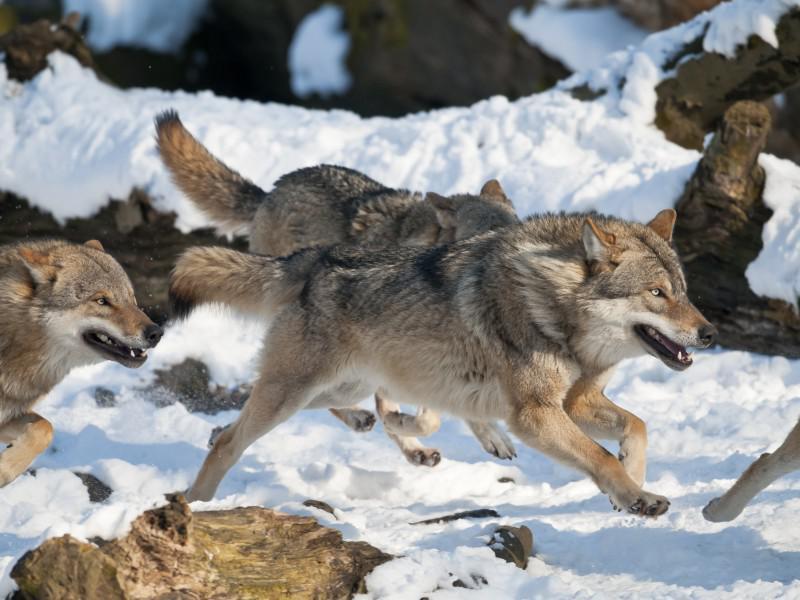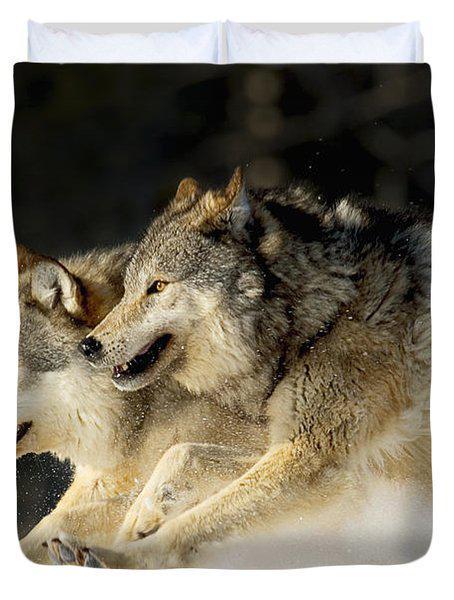The first image is the image on the left, the second image is the image on the right. For the images displayed, is the sentence "A single wolf is pictured sleeping in one of the images." factually correct? Answer yes or no. No. 